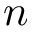<formula> <loc_0><loc_0><loc_500><loc_500>n</formula> 